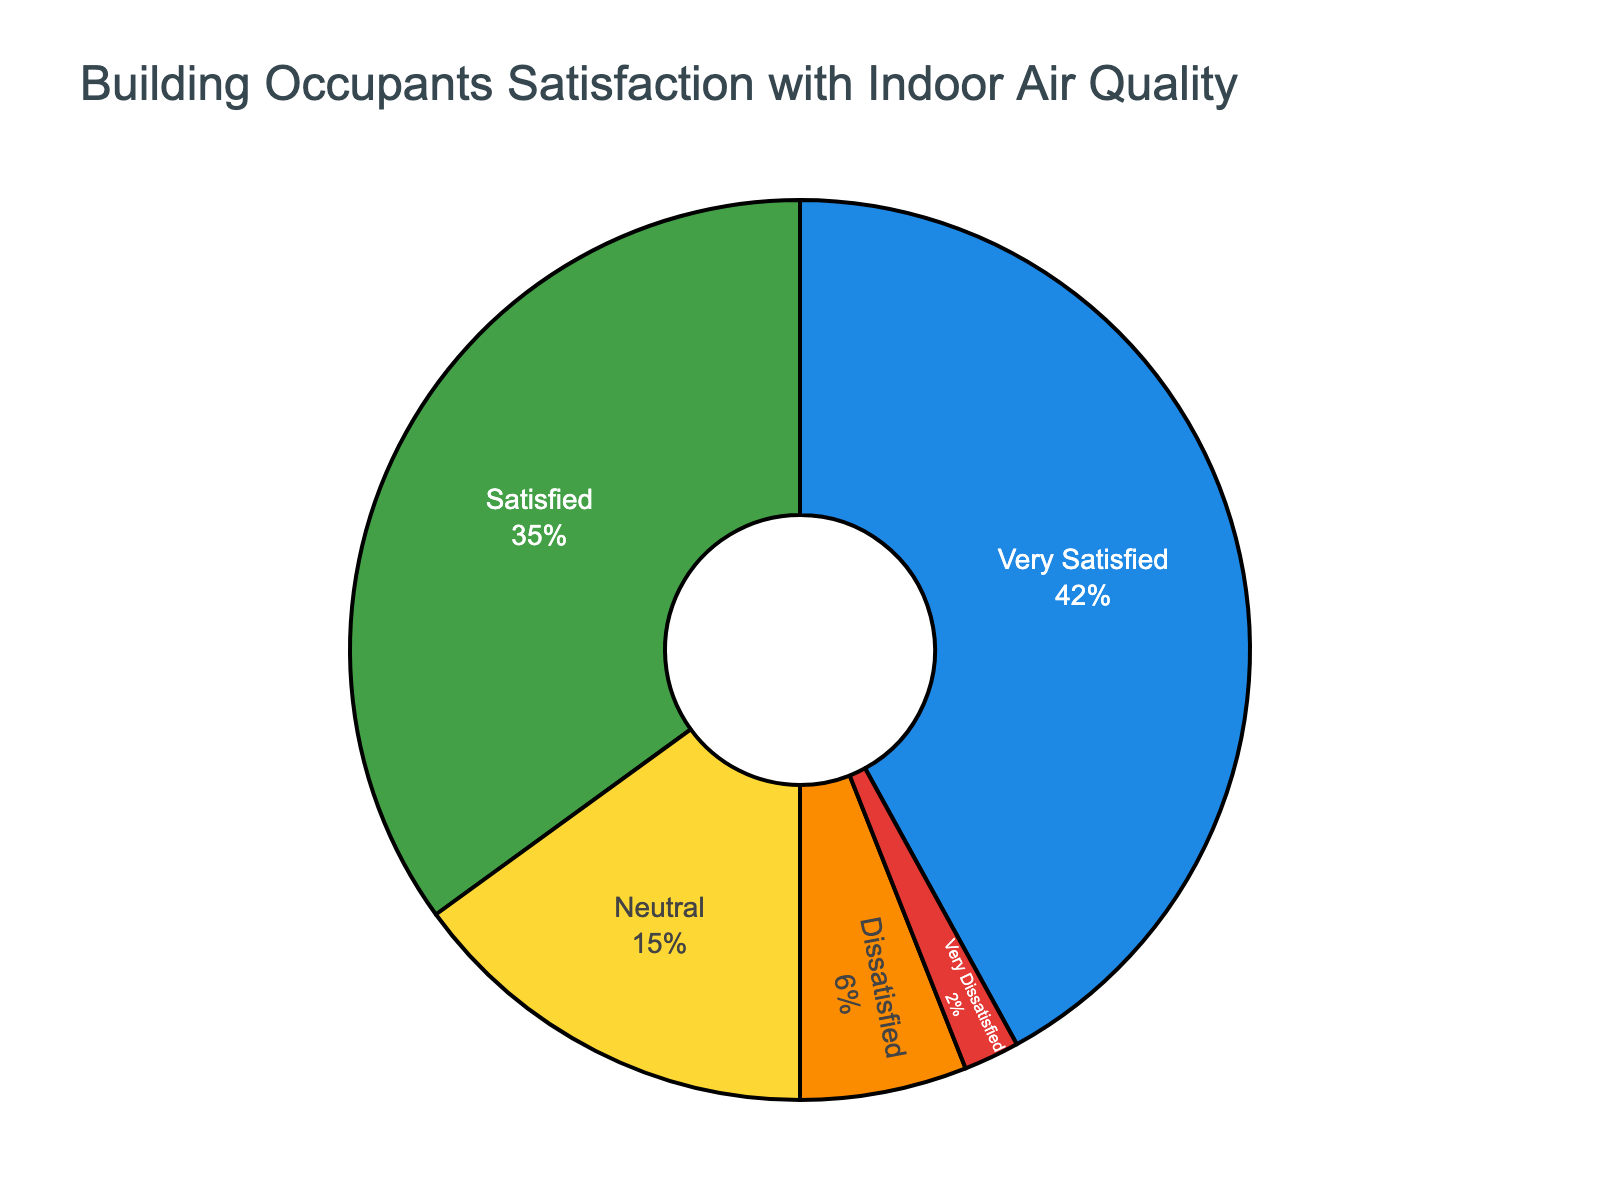What's the total percentage of occupants that are either Very Satisfied or Satisfied with the indoor air quality? To find the total percentage of occupants that are either Very Satisfied or Satisfied, add the percentages for both categories: 42% + 35% = 77%.
Answer: 77% How many percentage points more is the Very Satisfied category compared to the Dissatisfied category? Subtract the percentage of the Dissatisfied category from the percentage of the Very Satisfied category: 42% - 6% = 36%.
Answer: 36% Which category has the smallest percentage of occupants? By examining the pie chart, the "Very Dissatisfied" category occupies the smallest segment, indicating the smallest percentage.
Answer: Very Dissatisfied What is the difference in percentage between Neutral and Satisfied categories? Subtract the percentage of Neutral from Satisfied: 35% - 15% = 20%.
Answer: 20% What is the combined percentage of Neutral and Dissatisfied categories? Add the percentages of Neutral and Dissatisfied categories: 15% + 6% = 21%.
Answer: 21% If the total number of responses is 100, how many respondents are Very Dissatisfied with the indoor air quality? Multiply the total number of responses (100) by the percentage of Very Dissatisfied occupants (2%): 100 * 0.02 = 2.
Answer: 2 What fraction of occupants are either Neutral or Dissatisfied? Add the percentages for Neutral and Dissatisfied categories and then convert the percentage to a fraction: (15% + 6%) / 100 = 21/100.
Answer: 21/100 How much more significant is the Very Satisfied category compared to the Very Dissatisfied and Dissatisfied categories combined? First, find the combined percentage of Very Dissatisfied and Dissatisfied: 2% + 6% = 8%. Then subtract this from the Very Satisfied percentage: 42% - 8% = 34%.
Answer: 34% Which category falls right in the middle in terms of percentage coverage? The "Neutral" category, with 15%, falls in the middle of the provided percentages.
Answer: Neutral 